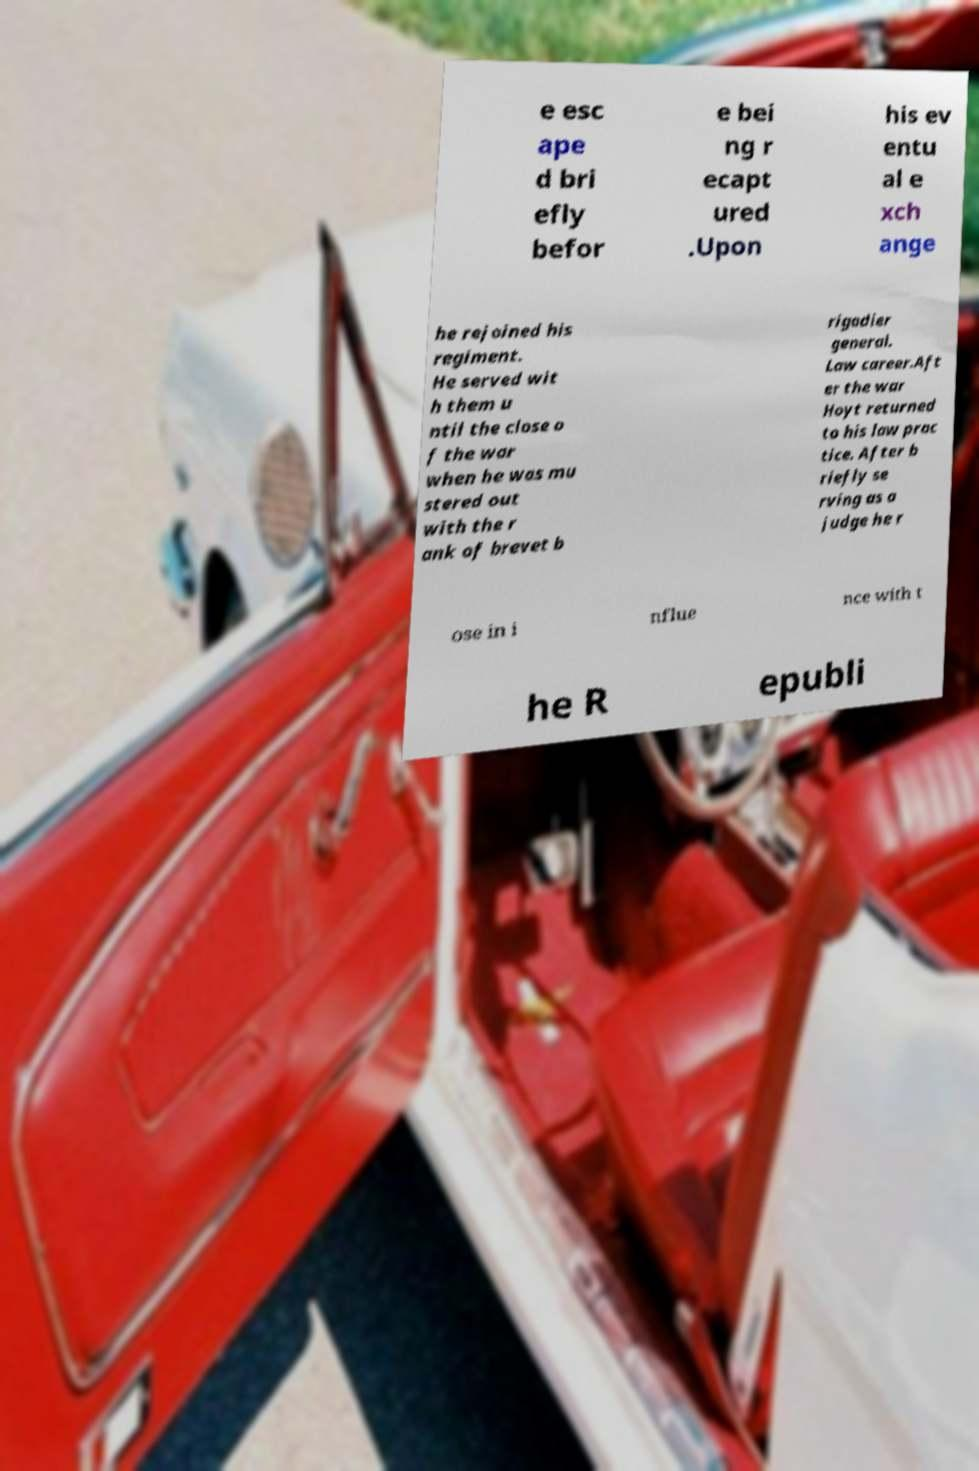There's text embedded in this image that I need extracted. Can you transcribe it verbatim? e esc ape d bri efly befor e bei ng r ecapt ured .Upon his ev entu al e xch ange he rejoined his regiment. He served wit h them u ntil the close o f the war when he was mu stered out with the r ank of brevet b rigadier general. Law career.Aft er the war Hoyt returned to his law prac tice. After b riefly se rving as a judge he r ose in i nflue nce with t he R epubli 